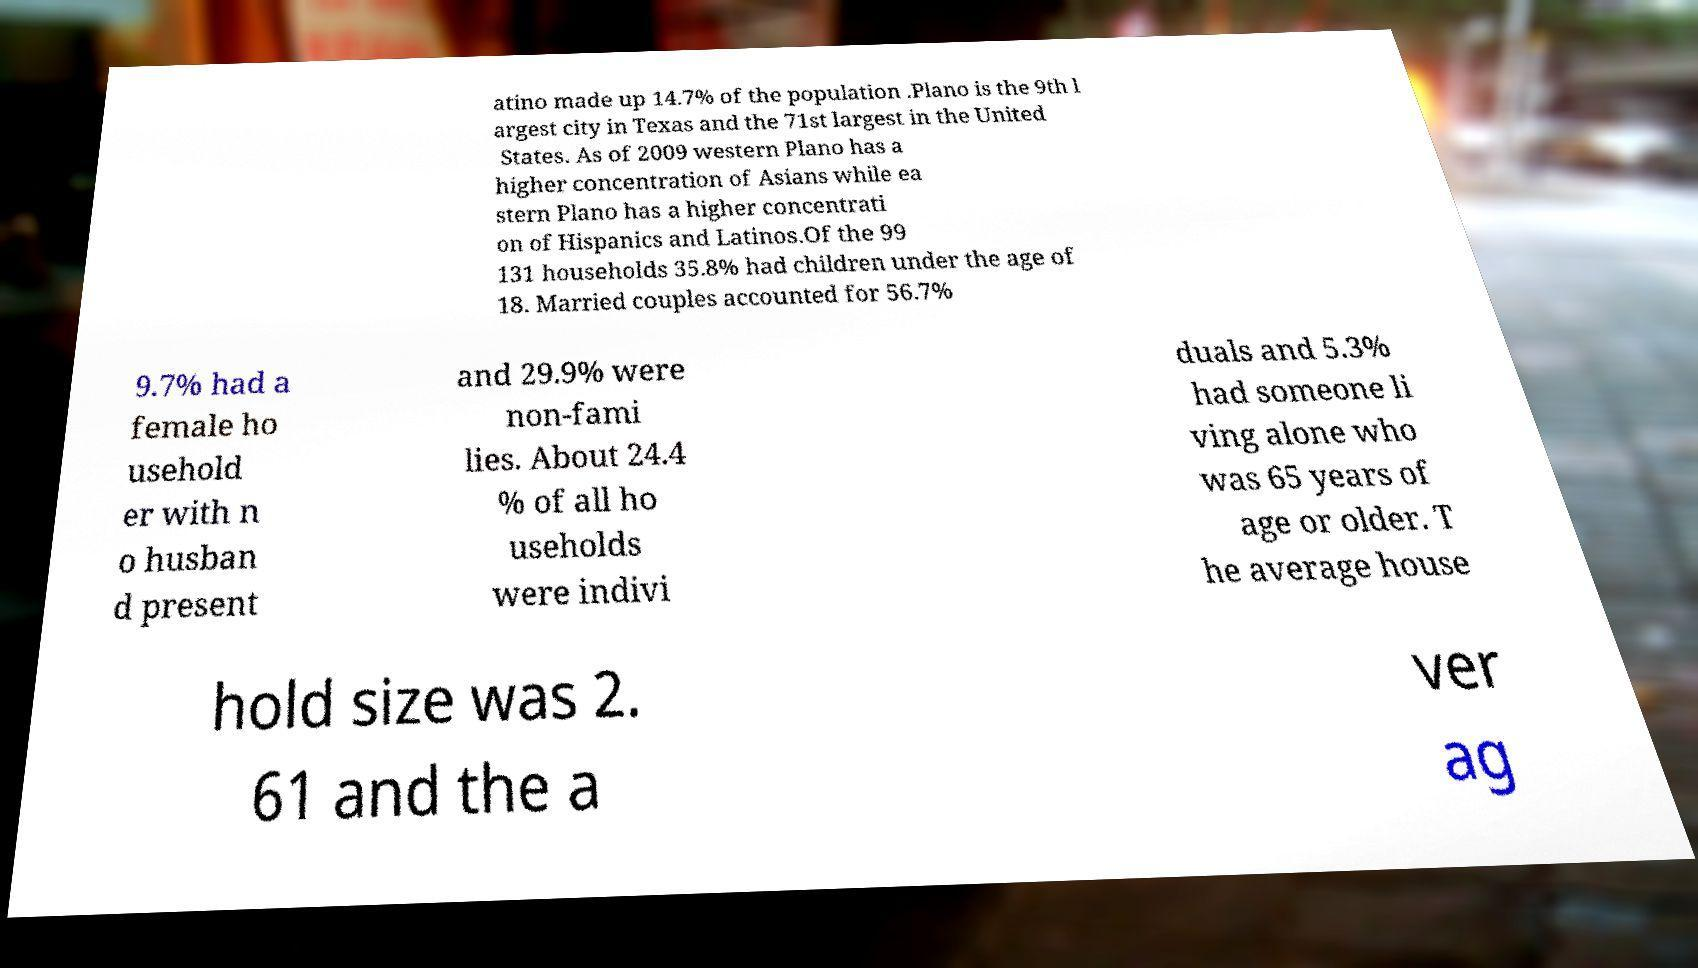Could you assist in decoding the text presented in this image and type it out clearly? atino made up 14.7% of the population .Plano is the 9th l argest city in Texas and the 71st largest in the United States. As of 2009 western Plano has a higher concentration of Asians while ea stern Plano has a higher concentrati on of Hispanics and Latinos.Of the 99 131 households 35.8% had children under the age of 18. Married couples accounted for 56.7% 9.7% had a female ho usehold er with n o husban d present and 29.9% were non-fami lies. About 24.4 % of all ho useholds were indivi duals and 5.3% had someone li ving alone who was 65 years of age or older. T he average house hold size was 2. 61 and the a ver ag 